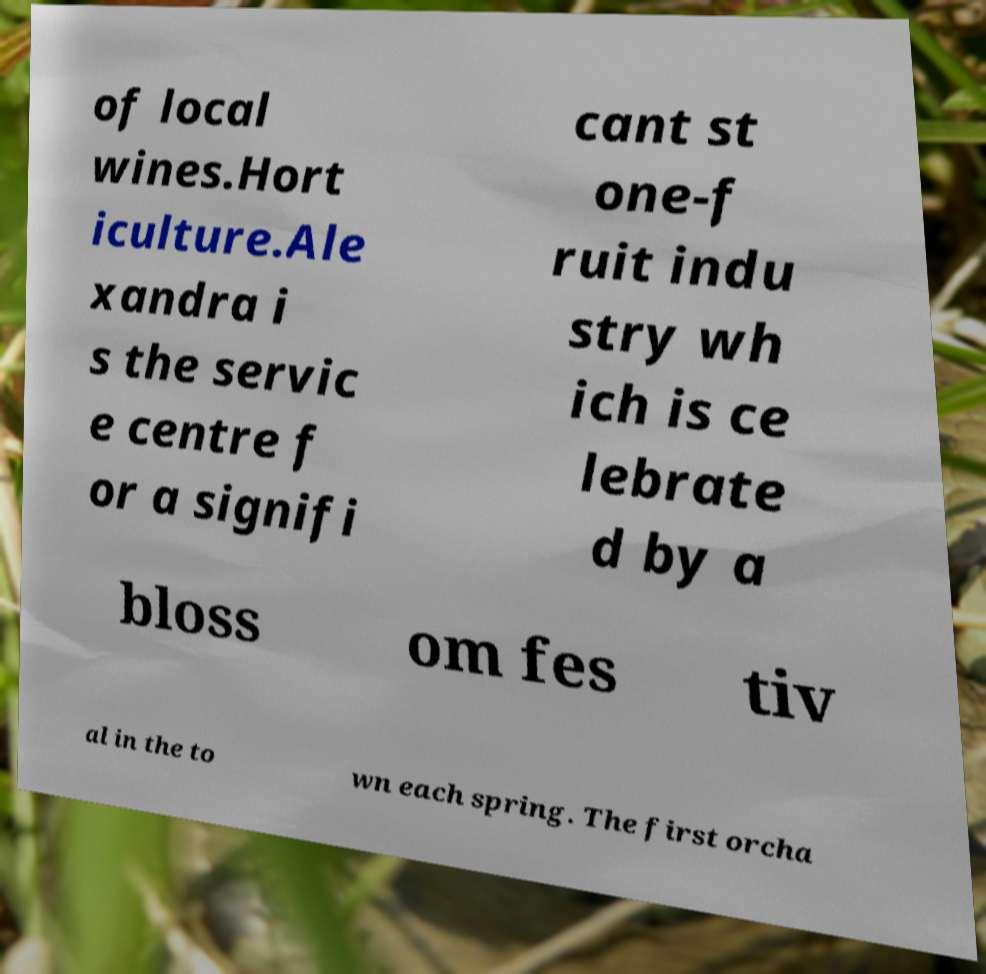What messages or text are displayed in this image? I need them in a readable, typed format. of local wines.Hort iculture.Ale xandra i s the servic e centre f or a signifi cant st one-f ruit indu stry wh ich is ce lebrate d by a bloss om fes tiv al in the to wn each spring. The first orcha 